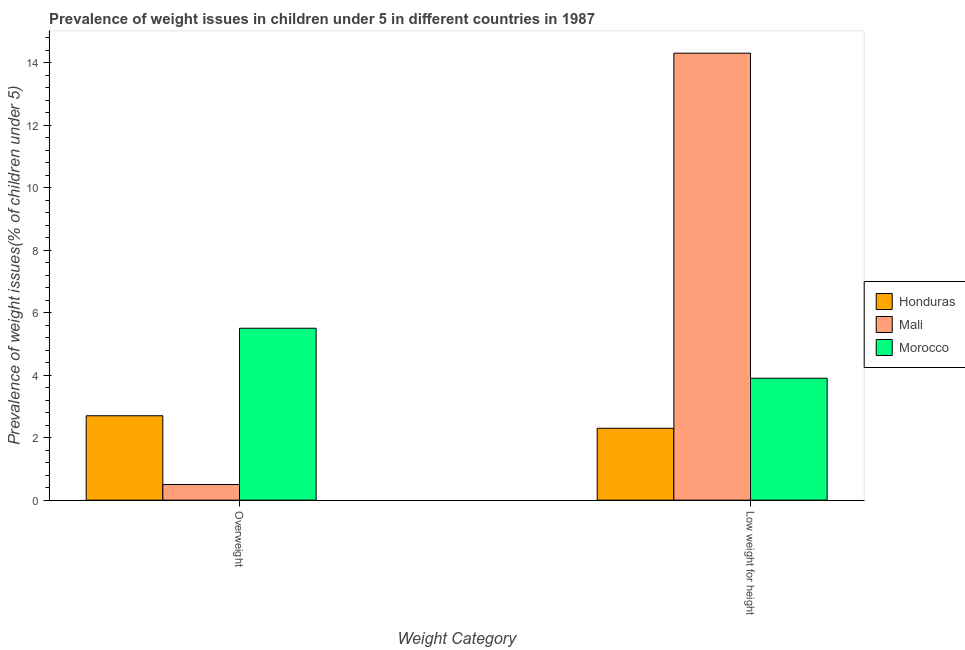How many different coloured bars are there?
Your answer should be compact. 3. How many bars are there on the 1st tick from the left?
Keep it short and to the point. 3. How many bars are there on the 1st tick from the right?
Offer a very short reply. 3. What is the label of the 1st group of bars from the left?
Keep it short and to the point. Overweight. Across all countries, what is the maximum percentage of underweight children?
Offer a terse response. 14.3. Across all countries, what is the minimum percentage of underweight children?
Offer a terse response. 2.3. In which country was the percentage of underweight children maximum?
Offer a terse response. Mali. In which country was the percentage of overweight children minimum?
Provide a succinct answer. Mali. What is the total percentage of underweight children in the graph?
Ensure brevity in your answer.  20.5. What is the difference between the percentage of underweight children in Mali and that in Honduras?
Ensure brevity in your answer.  12. What is the difference between the percentage of underweight children in Mali and the percentage of overweight children in Honduras?
Give a very brief answer. 11.6. What is the average percentage of overweight children per country?
Give a very brief answer. 2.9. What is the difference between the percentage of overweight children and percentage of underweight children in Mali?
Give a very brief answer. -13.8. In how many countries, is the percentage of overweight children greater than 11.6 %?
Give a very brief answer. 0. What is the ratio of the percentage of overweight children in Honduras to that in Mali?
Offer a terse response. 5.4. What does the 1st bar from the left in Low weight for height represents?
Keep it short and to the point. Honduras. What does the 3rd bar from the right in Overweight represents?
Offer a terse response. Honduras. How many bars are there?
Your answer should be very brief. 6. How many countries are there in the graph?
Offer a terse response. 3. What is the difference between two consecutive major ticks on the Y-axis?
Provide a short and direct response. 2. Are the values on the major ticks of Y-axis written in scientific E-notation?
Your answer should be very brief. No. Where does the legend appear in the graph?
Your answer should be very brief. Center right. How are the legend labels stacked?
Your answer should be compact. Vertical. What is the title of the graph?
Your response must be concise. Prevalence of weight issues in children under 5 in different countries in 1987. What is the label or title of the X-axis?
Offer a very short reply. Weight Category. What is the label or title of the Y-axis?
Offer a terse response. Prevalence of weight issues(% of children under 5). What is the Prevalence of weight issues(% of children under 5) in Honduras in Overweight?
Your answer should be very brief. 2.7. What is the Prevalence of weight issues(% of children under 5) in Mali in Overweight?
Provide a short and direct response. 0.5. What is the Prevalence of weight issues(% of children under 5) of Morocco in Overweight?
Your answer should be compact. 5.5. What is the Prevalence of weight issues(% of children under 5) in Honduras in Low weight for height?
Offer a very short reply. 2.3. What is the Prevalence of weight issues(% of children under 5) of Mali in Low weight for height?
Your response must be concise. 14.3. What is the Prevalence of weight issues(% of children under 5) of Morocco in Low weight for height?
Your response must be concise. 3.9. Across all Weight Category, what is the maximum Prevalence of weight issues(% of children under 5) of Honduras?
Your response must be concise. 2.7. Across all Weight Category, what is the maximum Prevalence of weight issues(% of children under 5) in Mali?
Your answer should be compact. 14.3. Across all Weight Category, what is the minimum Prevalence of weight issues(% of children under 5) in Honduras?
Provide a succinct answer. 2.3. Across all Weight Category, what is the minimum Prevalence of weight issues(% of children under 5) in Morocco?
Provide a succinct answer. 3.9. What is the total Prevalence of weight issues(% of children under 5) of Mali in the graph?
Provide a short and direct response. 14.8. What is the difference between the Prevalence of weight issues(% of children under 5) in Mali in Overweight and that in Low weight for height?
Provide a short and direct response. -13.8. What is the difference between the Prevalence of weight issues(% of children under 5) of Honduras in Overweight and the Prevalence of weight issues(% of children under 5) of Mali in Low weight for height?
Keep it short and to the point. -11.6. What is the difference between the Prevalence of weight issues(% of children under 5) in Honduras in Overweight and the Prevalence of weight issues(% of children under 5) in Morocco in Low weight for height?
Your answer should be compact. -1.2. What is the difference between the Prevalence of weight issues(% of children under 5) of Honduras and Prevalence of weight issues(% of children under 5) of Mali in Overweight?
Offer a terse response. 2.2. What is the difference between the Prevalence of weight issues(% of children under 5) in Honduras and Prevalence of weight issues(% of children under 5) in Morocco in Overweight?
Provide a short and direct response. -2.8. What is the difference between the Prevalence of weight issues(% of children under 5) in Honduras and Prevalence of weight issues(% of children under 5) in Morocco in Low weight for height?
Provide a short and direct response. -1.6. What is the difference between the Prevalence of weight issues(% of children under 5) of Mali and Prevalence of weight issues(% of children under 5) of Morocco in Low weight for height?
Give a very brief answer. 10.4. What is the ratio of the Prevalence of weight issues(% of children under 5) of Honduras in Overweight to that in Low weight for height?
Your response must be concise. 1.17. What is the ratio of the Prevalence of weight issues(% of children under 5) of Mali in Overweight to that in Low weight for height?
Give a very brief answer. 0.04. What is the ratio of the Prevalence of weight issues(% of children under 5) in Morocco in Overweight to that in Low weight for height?
Provide a short and direct response. 1.41. What is the difference between the highest and the second highest Prevalence of weight issues(% of children under 5) in Mali?
Offer a terse response. 13.8. What is the difference between the highest and the second highest Prevalence of weight issues(% of children under 5) of Morocco?
Keep it short and to the point. 1.6. What is the difference between the highest and the lowest Prevalence of weight issues(% of children under 5) of Honduras?
Your response must be concise. 0.4. What is the difference between the highest and the lowest Prevalence of weight issues(% of children under 5) in Mali?
Your answer should be very brief. 13.8. 